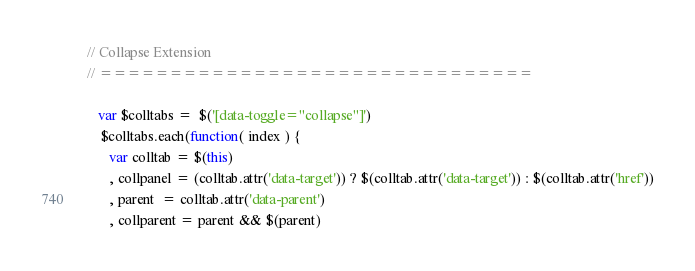Convert code to text. <code><loc_0><loc_0><loc_500><loc_500><_JavaScript_>
  // Collapse Extension
  // ===============================

     var $colltabs =  $('[data-toggle="collapse"]')      
      $colltabs.each(function( index ) {
        var colltab = $(this)
        , collpanel = (colltab.attr('data-target')) ? $(colltab.attr('data-target')) : $(colltab.attr('href'))
        , parent  = colltab.attr('data-parent')
        , collparent = parent && $(parent)</code> 